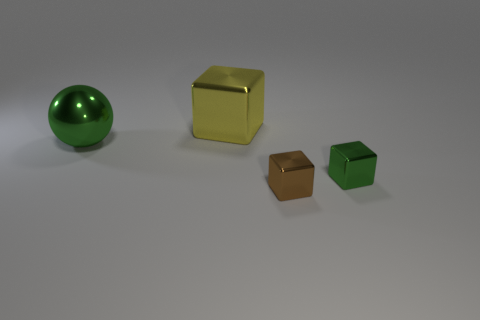Can you describe the texture and appearance of the objects depicted? Certainly! The objects in the image have a smooth, almost polished texture. The large sphere and the cubes exhibit a reflective surface, indicating that they are likely made from materials such as plastic or metal with a shiny finish. The lighting creates soft highlights and subtle shadows that contour the shapes, enhancing the three-dimensional effect. 